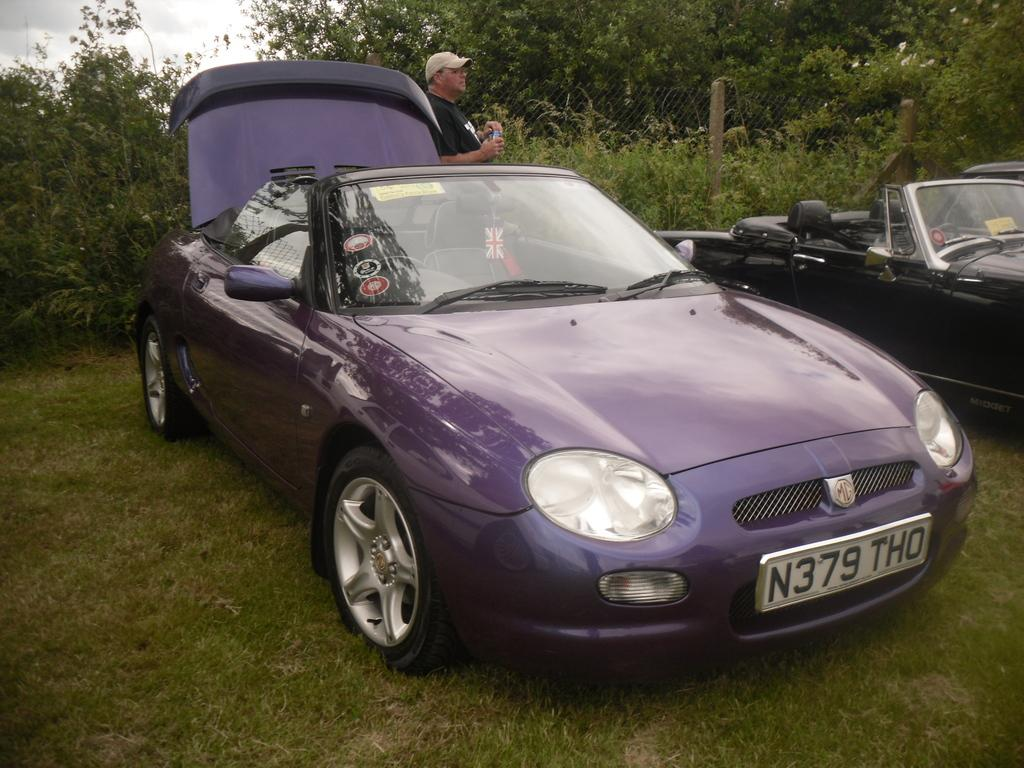What can be seen in the foreground of the picture? There are cars, grass, and a person in the foreground of the picture. What is located in the center of the picture? There are plants, trees, and fencing in the center of the picture. What is visible in the background of the picture? The sky is visible in the background of the picture. What is the condition of the sky in the picture? The sky is cloudy in the picture. Can you tell me how many beams are supporting the bridge in the image? There is no bridge or beam present in the image. Is there a stream visible in the foreground of the image? There is no stream visible in the image; it features cars, grass, and a person in the foreground. 